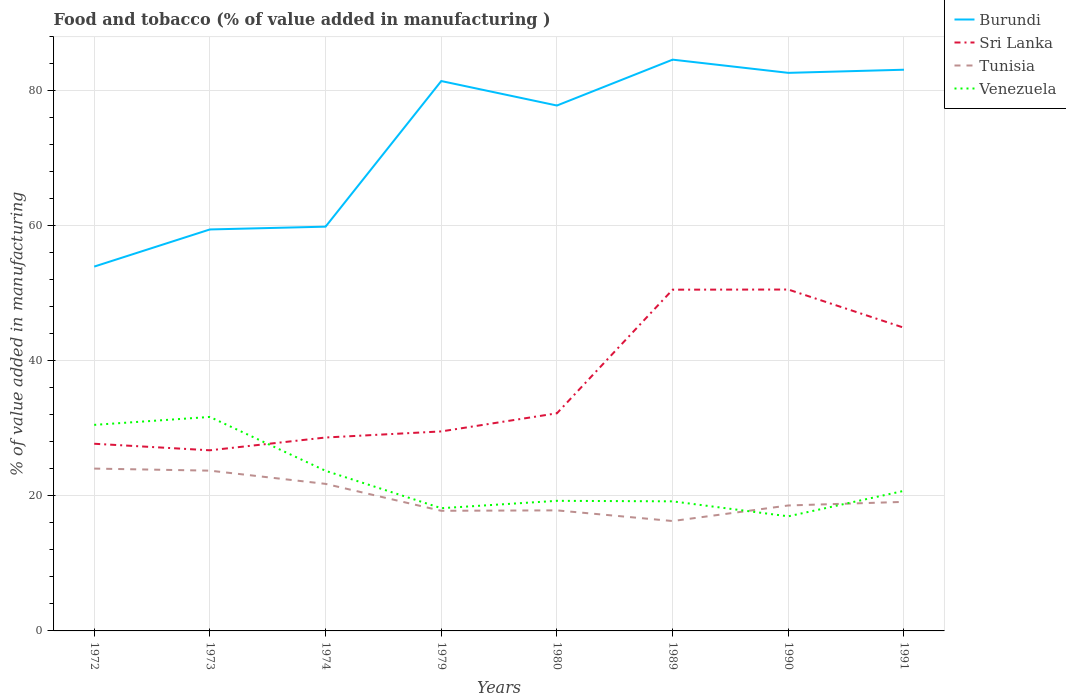How many different coloured lines are there?
Ensure brevity in your answer.  4. Is the number of lines equal to the number of legend labels?
Your answer should be compact. Yes. Across all years, what is the maximum value added in manufacturing food and tobacco in Sri Lanka?
Offer a terse response. 26.75. In which year was the value added in manufacturing food and tobacco in Tunisia maximum?
Your response must be concise. 1989. What is the total value added in manufacturing food and tobacco in Burundi in the graph?
Provide a short and direct response. -21.98. What is the difference between the highest and the second highest value added in manufacturing food and tobacco in Tunisia?
Offer a terse response. 7.77. What is the difference between the highest and the lowest value added in manufacturing food and tobacco in Venezuela?
Your answer should be very brief. 3. Is the value added in manufacturing food and tobacco in Tunisia strictly greater than the value added in manufacturing food and tobacco in Sri Lanka over the years?
Make the answer very short. Yes. How many lines are there?
Ensure brevity in your answer.  4. What is the difference between two consecutive major ticks on the Y-axis?
Your answer should be compact. 20. Are the values on the major ticks of Y-axis written in scientific E-notation?
Offer a terse response. No. Does the graph contain any zero values?
Offer a terse response. No. What is the title of the graph?
Provide a succinct answer. Food and tobacco (% of value added in manufacturing ). Does "World" appear as one of the legend labels in the graph?
Give a very brief answer. No. What is the label or title of the X-axis?
Provide a short and direct response. Years. What is the label or title of the Y-axis?
Ensure brevity in your answer.  % of value added in manufacturing. What is the % of value added in manufacturing in Burundi in 1972?
Ensure brevity in your answer.  53.96. What is the % of value added in manufacturing of Sri Lanka in 1972?
Your response must be concise. 27.72. What is the % of value added in manufacturing in Tunisia in 1972?
Provide a succinct answer. 24.04. What is the % of value added in manufacturing in Venezuela in 1972?
Your answer should be very brief. 30.52. What is the % of value added in manufacturing in Burundi in 1973?
Keep it short and to the point. 59.46. What is the % of value added in manufacturing in Sri Lanka in 1973?
Make the answer very short. 26.75. What is the % of value added in manufacturing in Tunisia in 1973?
Your answer should be very brief. 23.74. What is the % of value added in manufacturing in Venezuela in 1973?
Give a very brief answer. 31.69. What is the % of value added in manufacturing in Burundi in 1974?
Offer a very short reply. 59.87. What is the % of value added in manufacturing of Sri Lanka in 1974?
Keep it short and to the point. 28.65. What is the % of value added in manufacturing in Tunisia in 1974?
Offer a terse response. 21.78. What is the % of value added in manufacturing in Venezuela in 1974?
Keep it short and to the point. 23.71. What is the % of value added in manufacturing of Burundi in 1979?
Provide a short and direct response. 81.44. What is the % of value added in manufacturing in Sri Lanka in 1979?
Provide a succinct answer. 29.55. What is the % of value added in manufacturing in Tunisia in 1979?
Offer a very short reply. 17.79. What is the % of value added in manufacturing of Venezuela in 1979?
Keep it short and to the point. 18.18. What is the % of value added in manufacturing in Burundi in 1980?
Your answer should be compact. 77.81. What is the % of value added in manufacturing in Sri Lanka in 1980?
Offer a terse response. 32.23. What is the % of value added in manufacturing in Tunisia in 1980?
Keep it short and to the point. 17.85. What is the % of value added in manufacturing in Venezuela in 1980?
Your answer should be compact. 19.27. What is the % of value added in manufacturing in Burundi in 1989?
Your response must be concise. 84.61. What is the % of value added in manufacturing in Sri Lanka in 1989?
Provide a succinct answer. 50.54. What is the % of value added in manufacturing in Tunisia in 1989?
Provide a short and direct response. 16.27. What is the % of value added in manufacturing in Venezuela in 1989?
Your answer should be compact. 19.19. What is the % of value added in manufacturing of Burundi in 1990?
Provide a short and direct response. 82.65. What is the % of value added in manufacturing of Sri Lanka in 1990?
Keep it short and to the point. 50.56. What is the % of value added in manufacturing in Tunisia in 1990?
Your response must be concise. 18.58. What is the % of value added in manufacturing of Venezuela in 1990?
Make the answer very short. 16.97. What is the % of value added in manufacturing of Burundi in 1991?
Give a very brief answer. 83.12. What is the % of value added in manufacturing in Sri Lanka in 1991?
Offer a terse response. 44.9. What is the % of value added in manufacturing of Tunisia in 1991?
Give a very brief answer. 19.11. What is the % of value added in manufacturing of Venezuela in 1991?
Your answer should be very brief. 20.75. Across all years, what is the maximum % of value added in manufacturing in Burundi?
Offer a terse response. 84.61. Across all years, what is the maximum % of value added in manufacturing in Sri Lanka?
Offer a terse response. 50.56. Across all years, what is the maximum % of value added in manufacturing of Tunisia?
Offer a very short reply. 24.04. Across all years, what is the maximum % of value added in manufacturing of Venezuela?
Your answer should be very brief. 31.69. Across all years, what is the minimum % of value added in manufacturing of Burundi?
Your answer should be compact. 53.96. Across all years, what is the minimum % of value added in manufacturing of Sri Lanka?
Give a very brief answer. 26.75. Across all years, what is the minimum % of value added in manufacturing in Tunisia?
Keep it short and to the point. 16.27. Across all years, what is the minimum % of value added in manufacturing of Venezuela?
Ensure brevity in your answer.  16.97. What is the total % of value added in manufacturing in Burundi in the graph?
Your answer should be very brief. 582.91. What is the total % of value added in manufacturing of Sri Lanka in the graph?
Your answer should be very brief. 290.89. What is the total % of value added in manufacturing in Tunisia in the graph?
Make the answer very short. 159.17. What is the total % of value added in manufacturing in Venezuela in the graph?
Provide a succinct answer. 180.27. What is the difference between the % of value added in manufacturing in Burundi in 1972 and that in 1973?
Your answer should be compact. -5.5. What is the difference between the % of value added in manufacturing of Sri Lanka in 1972 and that in 1973?
Your answer should be compact. 0.97. What is the difference between the % of value added in manufacturing of Tunisia in 1972 and that in 1973?
Provide a succinct answer. 0.31. What is the difference between the % of value added in manufacturing in Venezuela in 1972 and that in 1973?
Make the answer very short. -1.18. What is the difference between the % of value added in manufacturing of Burundi in 1972 and that in 1974?
Make the answer very short. -5.91. What is the difference between the % of value added in manufacturing in Sri Lanka in 1972 and that in 1974?
Make the answer very short. -0.92. What is the difference between the % of value added in manufacturing in Tunisia in 1972 and that in 1974?
Keep it short and to the point. 2.27. What is the difference between the % of value added in manufacturing in Venezuela in 1972 and that in 1974?
Provide a short and direct response. 6.8. What is the difference between the % of value added in manufacturing in Burundi in 1972 and that in 1979?
Give a very brief answer. -27.48. What is the difference between the % of value added in manufacturing in Sri Lanka in 1972 and that in 1979?
Offer a terse response. -1.83. What is the difference between the % of value added in manufacturing of Tunisia in 1972 and that in 1979?
Give a very brief answer. 6.25. What is the difference between the % of value added in manufacturing in Venezuela in 1972 and that in 1979?
Your answer should be very brief. 12.34. What is the difference between the % of value added in manufacturing of Burundi in 1972 and that in 1980?
Provide a short and direct response. -23.85. What is the difference between the % of value added in manufacturing in Sri Lanka in 1972 and that in 1980?
Your answer should be very brief. -4.51. What is the difference between the % of value added in manufacturing of Tunisia in 1972 and that in 1980?
Provide a succinct answer. 6.19. What is the difference between the % of value added in manufacturing in Venezuela in 1972 and that in 1980?
Keep it short and to the point. 11.25. What is the difference between the % of value added in manufacturing in Burundi in 1972 and that in 1989?
Provide a succinct answer. -30.65. What is the difference between the % of value added in manufacturing of Sri Lanka in 1972 and that in 1989?
Offer a terse response. -22.82. What is the difference between the % of value added in manufacturing in Tunisia in 1972 and that in 1989?
Your response must be concise. 7.77. What is the difference between the % of value added in manufacturing of Venezuela in 1972 and that in 1989?
Your answer should be compact. 11.32. What is the difference between the % of value added in manufacturing of Burundi in 1972 and that in 1990?
Give a very brief answer. -28.69. What is the difference between the % of value added in manufacturing of Sri Lanka in 1972 and that in 1990?
Offer a terse response. -22.84. What is the difference between the % of value added in manufacturing in Tunisia in 1972 and that in 1990?
Your answer should be very brief. 5.46. What is the difference between the % of value added in manufacturing in Venezuela in 1972 and that in 1990?
Your answer should be very brief. 13.54. What is the difference between the % of value added in manufacturing of Burundi in 1972 and that in 1991?
Your response must be concise. -29.16. What is the difference between the % of value added in manufacturing of Sri Lanka in 1972 and that in 1991?
Give a very brief answer. -17.18. What is the difference between the % of value added in manufacturing in Tunisia in 1972 and that in 1991?
Your answer should be very brief. 4.93. What is the difference between the % of value added in manufacturing of Venezuela in 1972 and that in 1991?
Provide a succinct answer. 9.77. What is the difference between the % of value added in manufacturing of Burundi in 1973 and that in 1974?
Your answer should be very brief. -0.41. What is the difference between the % of value added in manufacturing of Sri Lanka in 1973 and that in 1974?
Your response must be concise. -1.89. What is the difference between the % of value added in manufacturing of Tunisia in 1973 and that in 1974?
Your response must be concise. 1.96. What is the difference between the % of value added in manufacturing in Venezuela in 1973 and that in 1974?
Ensure brevity in your answer.  7.98. What is the difference between the % of value added in manufacturing of Burundi in 1973 and that in 1979?
Offer a terse response. -21.98. What is the difference between the % of value added in manufacturing of Sri Lanka in 1973 and that in 1979?
Your answer should be very brief. -2.8. What is the difference between the % of value added in manufacturing in Tunisia in 1973 and that in 1979?
Offer a very short reply. 5.94. What is the difference between the % of value added in manufacturing in Venezuela in 1973 and that in 1979?
Make the answer very short. 13.52. What is the difference between the % of value added in manufacturing in Burundi in 1973 and that in 1980?
Make the answer very short. -18.35. What is the difference between the % of value added in manufacturing of Sri Lanka in 1973 and that in 1980?
Make the answer very short. -5.48. What is the difference between the % of value added in manufacturing of Tunisia in 1973 and that in 1980?
Make the answer very short. 5.88. What is the difference between the % of value added in manufacturing in Venezuela in 1973 and that in 1980?
Your response must be concise. 12.42. What is the difference between the % of value added in manufacturing in Burundi in 1973 and that in 1989?
Offer a terse response. -25.15. What is the difference between the % of value added in manufacturing in Sri Lanka in 1973 and that in 1989?
Keep it short and to the point. -23.79. What is the difference between the % of value added in manufacturing in Tunisia in 1973 and that in 1989?
Your response must be concise. 7.46. What is the difference between the % of value added in manufacturing in Venezuela in 1973 and that in 1989?
Give a very brief answer. 12.5. What is the difference between the % of value added in manufacturing in Burundi in 1973 and that in 1990?
Offer a terse response. -23.19. What is the difference between the % of value added in manufacturing in Sri Lanka in 1973 and that in 1990?
Provide a short and direct response. -23.81. What is the difference between the % of value added in manufacturing of Tunisia in 1973 and that in 1990?
Provide a succinct answer. 5.16. What is the difference between the % of value added in manufacturing of Venezuela in 1973 and that in 1990?
Make the answer very short. 14.72. What is the difference between the % of value added in manufacturing in Burundi in 1973 and that in 1991?
Provide a short and direct response. -23.66. What is the difference between the % of value added in manufacturing of Sri Lanka in 1973 and that in 1991?
Ensure brevity in your answer.  -18.15. What is the difference between the % of value added in manufacturing in Tunisia in 1973 and that in 1991?
Give a very brief answer. 4.62. What is the difference between the % of value added in manufacturing of Venezuela in 1973 and that in 1991?
Give a very brief answer. 10.94. What is the difference between the % of value added in manufacturing of Burundi in 1974 and that in 1979?
Your answer should be compact. -21.57. What is the difference between the % of value added in manufacturing in Sri Lanka in 1974 and that in 1979?
Keep it short and to the point. -0.9. What is the difference between the % of value added in manufacturing of Tunisia in 1974 and that in 1979?
Keep it short and to the point. 3.99. What is the difference between the % of value added in manufacturing in Venezuela in 1974 and that in 1979?
Provide a succinct answer. 5.54. What is the difference between the % of value added in manufacturing in Burundi in 1974 and that in 1980?
Give a very brief answer. -17.94. What is the difference between the % of value added in manufacturing in Sri Lanka in 1974 and that in 1980?
Give a very brief answer. -3.59. What is the difference between the % of value added in manufacturing in Tunisia in 1974 and that in 1980?
Keep it short and to the point. 3.92. What is the difference between the % of value added in manufacturing of Venezuela in 1974 and that in 1980?
Give a very brief answer. 4.45. What is the difference between the % of value added in manufacturing in Burundi in 1974 and that in 1989?
Your answer should be very brief. -24.74. What is the difference between the % of value added in manufacturing of Sri Lanka in 1974 and that in 1989?
Keep it short and to the point. -21.89. What is the difference between the % of value added in manufacturing of Tunisia in 1974 and that in 1989?
Your answer should be very brief. 5.5. What is the difference between the % of value added in manufacturing in Venezuela in 1974 and that in 1989?
Make the answer very short. 4.52. What is the difference between the % of value added in manufacturing of Burundi in 1974 and that in 1990?
Your answer should be very brief. -22.78. What is the difference between the % of value added in manufacturing in Sri Lanka in 1974 and that in 1990?
Ensure brevity in your answer.  -21.92. What is the difference between the % of value added in manufacturing in Tunisia in 1974 and that in 1990?
Offer a very short reply. 3.2. What is the difference between the % of value added in manufacturing of Venezuela in 1974 and that in 1990?
Provide a short and direct response. 6.74. What is the difference between the % of value added in manufacturing in Burundi in 1974 and that in 1991?
Provide a short and direct response. -23.24. What is the difference between the % of value added in manufacturing of Sri Lanka in 1974 and that in 1991?
Provide a short and direct response. -16.25. What is the difference between the % of value added in manufacturing of Tunisia in 1974 and that in 1991?
Your answer should be very brief. 2.66. What is the difference between the % of value added in manufacturing of Venezuela in 1974 and that in 1991?
Offer a very short reply. 2.96. What is the difference between the % of value added in manufacturing in Burundi in 1979 and that in 1980?
Ensure brevity in your answer.  3.62. What is the difference between the % of value added in manufacturing in Sri Lanka in 1979 and that in 1980?
Provide a succinct answer. -2.68. What is the difference between the % of value added in manufacturing of Tunisia in 1979 and that in 1980?
Make the answer very short. -0.06. What is the difference between the % of value added in manufacturing of Venezuela in 1979 and that in 1980?
Give a very brief answer. -1.09. What is the difference between the % of value added in manufacturing of Burundi in 1979 and that in 1989?
Make the answer very short. -3.17. What is the difference between the % of value added in manufacturing of Sri Lanka in 1979 and that in 1989?
Offer a terse response. -20.99. What is the difference between the % of value added in manufacturing of Tunisia in 1979 and that in 1989?
Ensure brevity in your answer.  1.52. What is the difference between the % of value added in manufacturing of Venezuela in 1979 and that in 1989?
Provide a succinct answer. -1.01. What is the difference between the % of value added in manufacturing of Burundi in 1979 and that in 1990?
Offer a very short reply. -1.21. What is the difference between the % of value added in manufacturing in Sri Lanka in 1979 and that in 1990?
Your response must be concise. -21.01. What is the difference between the % of value added in manufacturing of Tunisia in 1979 and that in 1990?
Provide a short and direct response. -0.79. What is the difference between the % of value added in manufacturing in Venezuela in 1979 and that in 1990?
Your answer should be very brief. 1.2. What is the difference between the % of value added in manufacturing of Burundi in 1979 and that in 1991?
Your answer should be compact. -1.68. What is the difference between the % of value added in manufacturing in Sri Lanka in 1979 and that in 1991?
Ensure brevity in your answer.  -15.35. What is the difference between the % of value added in manufacturing in Tunisia in 1979 and that in 1991?
Offer a very short reply. -1.32. What is the difference between the % of value added in manufacturing in Venezuela in 1979 and that in 1991?
Your answer should be compact. -2.57. What is the difference between the % of value added in manufacturing of Burundi in 1980 and that in 1989?
Your answer should be very brief. -6.79. What is the difference between the % of value added in manufacturing of Sri Lanka in 1980 and that in 1989?
Offer a very short reply. -18.31. What is the difference between the % of value added in manufacturing in Tunisia in 1980 and that in 1989?
Your answer should be compact. 1.58. What is the difference between the % of value added in manufacturing of Venezuela in 1980 and that in 1989?
Make the answer very short. 0.08. What is the difference between the % of value added in manufacturing of Burundi in 1980 and that in 1990?
Offer a terse response. -4.84. What is the difference between the % of value added in manufacturing of Sri Lanka in 1980 and that in 1990?
Provide a succinct answer. -18.33. What is the difference between the % of value added in manufacturing in Tunisia in 1980 and that in 1990?
Your answer should be very brief. -0.73. What is the difference between the % of value added in manufacturing in Venezuela in 1980 and that in 1990?
Provide a short and direct response. 2.3. What is the difference between the % of value added in manufacturing in Burundi in 1980 and that in 1991?
Ensure brevity in your answer.  -5.3. What is the difference between the % of value added in manufacturing of Sri Lanka in 1980 and that in 1991?
Provide a succinct answer. -12.67. What is the difference between the % of value added in manufacturing of Tunisia in 1980 and that in 1991?
Make the answer very short. -1.26. What is the difference between the % of value added in manufacturing in Venezuela in 1980 and that in 1991?
Keep it short and to the point. -1.48. What is the difference between the % of value added in manufacturing in Burundi in 1989 and that in 1990?
Make the answer very short. 1.96. What is the difference between the % of value added in manufacturing in Sri Lanka in 1989 and that in 1990?
Keep it short and to the point. -0.02. What is the difference between the % of value added in manufacturing in Tunisia in 1989 and that in 1990?
Your answer should be compact. -2.31. What is the difference between the % of value added in manufacturing of Venezuela in 1989 and that in 1990?
Provide a succinct answer. 2.22. What is the difference between the % of value added in manufacturing in Burundi in 1989 and that in 1991?
Your answer should be very brief. 1.49. What is the difference between the % of value added in manufacturing in Sri Lanka in 1989 and that in 1991?
Provide a short and direct response. 5.64. What is the difference between the % of value added in manufacturing in Tunisia in 1989 and that in 1991?
Make the answer very short. -2.84. What is the difference between the % of value added in manufacturing of Venezuela in 1989 and that in 1991?
Offer a very short reply. -1.56. What is the difference between the % of value added in manufacturing in Burundi in 1990 and that in 1991?
Your response must be concise. -0.47. What is the difference between the % of value added in manufacturing of Sri Lanka in 1990 and that in 1991?
Your response must be concise. 5.66. What is the difference between the % of value added in manufacturing in Tunisia in 1990 and that in 1991?
Offer a terse response. -0.53. What is the difference between the % of value added in manufacturing of Venezuela in 1990 and that in 1991?
Provide a succinct answer. -3.78. What is the difference between the % of value added in manufacturing of Burundi in 1972 and the % of value added in manufacturing of Sri Lanka in 1973?
Your response must be concise. 27.21. What is the difference between the % of value added in manufacturing in Burundi in 1972 and the % of value added in manufacturing in Tunisia in 1973?
Give a very brief answer. 30.22. What is the difference between the % of value added in manufacturing in Burundi in 1972 and the % of value added in manufacturing in Venezuela in 1973?
Make the answer very short. 22.27. What is the difference between the % of value added in manufacturing in Sri Lanka in 1972 and the % of value added in manufacturing in Tunisia in 1973?
Give a very brief answer. 3.98. What is the difference between the % of value added in manufacturing in Sri Lanka in 1972 and the % of value added in manufacturing in Venezuela in 1973?
Offer a terse response. -3.97. What is the difference between the % of value added in manufacturing of Tunisia in 1972 and the % of value added in manufacturing of Venezuela in 1973?
Give a very brief answer. -7.65. What is the difference between the % of value added in manufacturing of Burundi in 1972 and the % of value added in manufacturing of Sri Lanka in 1974?
Your answer should be compact. 25.31. What is the difference between the % of value added in manufacturing in Burundi in 1972 and the % of value added in manufacturing in Tunisia in 1974?
Your response must be concise. 32.18. What is the difference between the % of value added in manufacturing of Burundi in 1972 and the % of value added in manufacturing of Venezuela in 1974?
Offer a very short reply. 30.25. What is the difference between the % of value added in manufacturing of Sri Lanka in 1972 and the % of value added in manufacturing of Tunisia in 1974?
Your answer should be compact. 5.94. What is the difference between the % of value added in manufacturing of Sri Lanka in 1972 and the % of value added in manufacturing of Venezuela in 1974?
Keep it short and to the point. 4.01. What is the difference between the % of value added in manufacturing in Tunisia in 1972 and the % of value added in manufacturing in Venezuela in 1974?
Offer a very short reply. 0.33. What is the difference between the % of value added in manufacturing in Burundi in 1972 and the % of value added in manufacturing in Sri Lanka in 1979?
Give a very brief answer. 24.41. What is the difference between the % of value added in manufacturing in Burundi in 1972 and the % of value added in manufacturing in Tunisia in 1979?
Give a very brief answer. 36.17. What is the difference between the % of value added in manufacturing in Burundi in 1972 and the % of value added in manufacturing in Venezuela in 1979?
Offer a very short reply. 35.78. What is the difference between the % of value added in manufacturing in Sri Lanka in 1972 and the % of value added in manufacturing in Tunisia in 1979?
Your response must be concise. 9.93. What is the difference between the % of value added in manufacturing in Sri Lanka in 1972 and the % of value added in manufacturing in Venezuela in 1979?
Your answer should be very brief. 9.54. What is the difference between the % of value added in manufacturing in Tunisia in 1972 and the % of value added in manufacturing in Venezuela in 1979?
Ensure brevity in your answer.  5.87. What is the difference between the % of value added in manufacturing in Burundi in 1972 and the % of value added in manufacturing in Sri Lanka in 1980?
Keep it short and to the point. 21.73. What is the difference between the % of value added in manufacturing of Burundi in 1972 and the % of value added in manufacturing of Tunisia in 1980?
Offer a terse response. 36.1. What is the difference between the % of value added in manufacturing of Burundi in 1972 and the % of value added in manufacturing of Venezuela in 1980?
Your answer should be compact. 34.69. What is the difference between the % of value added in manufacturing in Sri Lanka in 1972 and the % of value added in manufacturing in Tunisia in 1980?
Make the answer very short. 9.87. What is the difference between the % of value added in manufacturing in Sri Lanka in 1972 and the % of value added in manufacturing in Venezuela in 1980?
Provide a short and direct response. 8.45. What is the difference between the % of value added in manufacturing of Tunisia in 1972 and the % of value added in manufacturing of Venezuela in 1980?
Your answer should be very brief. 4.78. What is the difference between the % of value added in manufacturing in Burundi in 1972 and the % of value added in manufacturing in Sri Lanka in 1989?
Provide a succinct answer. 3.42. What is the difference between the % of value added in manufacturing of Burundi in 1972 and the % of value added in manufacturing of Tunisia in 1989?
Make the answer very short. 37.68. What is the difference between the % of value added in manufacturing in Burundi in 1972 and the % of value added in manufacturing in Venezuela in 1989?
Offer a very short reply. 34.77. What is the difference between the % of value added in manufacturing of Sri Lanka in 1972 and the % of value added in manufacturing of Tunisia in 1989?
Your answer should be compact. 11.45. What is the difference between the % of value added in manufacturing in Sri Lanka in 1972 and the % of value added in manufacturing in Venezuela in 1989?
Ensure brevity in your answer.  8.53. What is the difference between the % of value added in manufacturing in Tunisia in 1972 and the % of value added in manufacturing in Venezuela in 1989?
Ensure brevity in your answer.  4.85. What is the difference between the % of value added in manufacturing in Burundi in 1972 and the % of value added in manufacturing in Sri Lanka in 1990?
Your answer should be very brief. 3.4. What is the difference between the % of value added in manufacturing of Burundi in 1972 and the % of value added in manufacturing of Tunisia in 1990?
Make the answer very short. 35.38. What is the difference between the % of value added in manufacturing in Burundi in 1972 and the % of value added in manufacturing in Venezuela in 1990?
Offer a very short reply. 36.99. What is the difference between the % of value added in manufacturing in Sri Lanka in 1972 and the % of value added in manufacturing in Tunisia in 1990?
Your response must be concise. 9.14. What is the difference between the % of value added in manufacturing in Sri Lanka in 1972 and the % of value added in manufacturing in Venezuela in 1990?
Ensure brevity in your answer.  10.75. What is the difference between the % of value added in manufacturing of Tunisia in 1972 and the % of value added in manufacturing of Venezuela in 1990?
Your response must be concise. 7.07. What is the difference between the % of value added in manufacturing of Burundi in 1972 and the % of value added in manufacturing of Sri Lanka in 1991?
Make the answer very short. 9.06. What is the difference between the % of value added in manufacturing in Burundi in 1972 and the % of value added in manufacturing in Tunisia in 1991?
Keep it short and to the point. 34.85. What is the difference between the % of value added in manufacturing in Burundi in 1972 and the % of value added in manufacturing in Venezuela in 1991?
Offer a very short reply. 33.21. What is the difference between the % of value added in manufacturing in Sri Lanka in 1972 and the % of value added in manufacturing in Tunisia in 1991?
Your answer should be very brief. 8.61. What is the difference between the % of value added in manufacturing in Sri Lanka in 1972 and the % of value added in manufacturing in Venezuela in 1991?
Provide a succinct answer. 6.97. What is the difference between the % of value added in manufacturing in Tunisia in 1972 and the % of value added in manufacturing in Venezuela in 1991?
Give a very brief answer. 3.29. What is the difference between the % of value added in manufacturing in Burundi in 1973 and the % of value added in manufacturing in Sri Lanka in 1974?
Offer a terse response. 30.81. What is the difference between the % of value added in manufacturing in Burundi in 1973 and the % of value added in manufacturing in Tunisia in 1974?
Provide a succinct answer. 37.68. What is the difference between the % of value added in manufacturing of Burundi in 1973 and the % of value added in manufacturing of Venezuela in 1974?
Ensure brevity in your answer.  35.75. What is the difference between the % of value added in manufacturing in Sri Lanka in 1973 and the % of value added in manufacturing in Tunisia in 1974?
Keep it short and to the point. 4.97. What is the difference between the % of value added in manufacturing of Sri Lanka in 1973 and the % of value added in manufacturing of Venezuela in 1974?
Your answer should be compact. 3.04. What is the difference between the % of value added in manufacturing in Tunisia in 1973 and the % of value added in manufacturing in Venezuela in 1974?
Provide a short and direct response. 0.02. What is the difference between the % of value added in manufacturing in Burundi in 1973 and the % of value added in manufacturing in Sri Lanka in 1979?
Provide a short and direct response. 29.91. What is the difference between the % of value added in manufacturing of Burundi in 1973 and the % of value added in manufacturing of Tunisia in 1979?
Your response must be concise. 41.67. What is the difference between the % of value added in manufacturing of Burundi in 1973 and the % of value added in manufacturing of Venezuela in 1979?
Provide a succinct answer. 41.28. What is the difference between the % of value added in manufacturing in Sri Lanka in 1973 and the % of value added in manufacturing in Tunisia in 1979?
Keep it short and to the point. 8.96. What is the difference between the % of value added in manufacturing of Sri Lanka in 1973 and the % of value added in manufacturing of Venezuela in 1979?
Your response must be concise. 8.58. What is the difference between the % of value added in manufacturing of Tunisia in 1973 and the % of value added in manufacturing of Venezuela in 1979?
Your answer should be compact. 5.56. What is the difference between the % of value added in manufacturing of Burundi in 1973 and the % of value added in manufacturing of Sri Lanka in 1980?
Your response must be concise. 27.23. What is the difference between the % of value added in manufacturing in Burundi in 1973 and the % of value added in manufacturing in Tunisia in 1980?
Provide a succinct answer. 41.6. What is the difference between the % of value added in manufacturing in Burundi in 1973 and the % of value added in manufacturing in Venezuela in 1980?
Make the answer very short. 40.19. What is the difference between the % of value added in manufacturing of Sri Lanka in 1973 and the % of value added in manufacturing of Tunisia in 1980?
Offer a terse response. 8.9. What is the difference between the % of value added in manufacturing in Sri Lanka in 1973 and the % of value added in manufacturing in Venezuela in 1980?
Your answer should be very brief. 7.48. What is the difference between the % of value added in manufacturing in Tunisia in 1973 and the % of value added in manufacturing in Venezuela in 1980?
Offer a very short reply. 4.47. What is the difference between the % of value added in manufacturing in Burundi in 1973 and the % of value added in manufacturing in Sri Lanka in 1989?
Give a very brief answer. 8.92. What is the difference between the % of value added in manufacturing in Burundi in 1973 and the % of value added in manufacturing in Tunisia in 1989?
Make the answer very short. 43.19. What is the difference between the % of value added in manufacturing in Burundi in 1973 and the % of value added in manufacturing in Venezuela in 1989?
Offer a very short reply. 40.27. What is the difference between the % of value added in manufacturing in Sri Lanka in 1973 and the % of value added in manufacturing in Tunisia in 1989?
Your answer should be compact. 10.48. What is the difference between the % of value added in manufacturing in Sri Lanka in 1973 and the % of value added in manufacturing in Venezuela in 1989?
Provide a succinct answer. 7.56. What is the difference between the % of value added in manufacturing of Tunisia in 1973 and the % of value added in manufacturing of Venezuela in 1989?
Your answer should be very brief. 4.55. What is the difference between the % of value added in manufacturing of Burundi in 1973 and the % of value added in manufacturing of Sri Lanka in 1990?
Your answer should be very brief. 8.9. What is the difference between the % of value added in manufacturing of Burundi in 1973 and the % of value added in manufacturing of Tunisia in 1990?
Offer a very short reply. 40.88. What is the difference between the % of value added in manufacturing in Burundi in 1973 and the % of value added in manufacturing in Venezuela in 1990?
Give a very brief answer. 42.49. What is the difference between the % of value added in manufacturing of Sri Lanka in 1973 and the % of value added in manufacturing of Tunisia in 1990?
Offer a very short reply. 8.17. What is the difference between the % of value added in manufacturing of Sri Lanka in 1973 and the % of value added in manufacturing of Venezuela in 1990?
Provide a short and direct response. 9.78. What is the difference between the % of value added in manufacturing in Tunisia in 1973 and the % of value added in manufacturing in Venezuela in 1990?
Give a very brief answer. 6.76. What is the difference between the % of value added in manufacturing in Burundi in 1973 and the % of value added in manufacturing in Sri Lanka in 1991?
Your answer should be very brief. 14.56. What is the difference between the % of value added in manufacturing of Burundi in 1973 and the % of value added in manufacturing of Tunisia in 1991?
Make the answer very short. 40.35. What is the difference between the % of value added in manufacturing of Burundi in 1973 and the % of value added in manufacturing of Venezuela in 1991?
Your response must be concise. 38.71. What is the difference between the % of value added in manufacturing in Sri Lanka in 1973 and the % of value added in manufacturing in Tunisia in 1991?
Provide a succinct answer. 7.64. What is the difference between the % of value added in manufacturing in Sri Lanka in 1973 and the % of value added in manufacturing in Venezuela in 1991?
Offer a terse response. 6. What is the difference between the % of value added in manufacturing of Tunisia in 1973 and the % of value added in manufacturing of Venezuela in 1991?
Your response must be concise. 2.99. What is the difference between the % of value added in manufacturing of Burundi in 1974 and the % of value added in manufacturing of Sri Lanka in 1979?
Provide a succinct answer. 30.32. What is the difference between the % of value added in manufacturing of Burundi in 1974 and the % of value added in manufacturing of Tunisia in 1979?
Provide a short and direct response. 42.08. What is the difference between the % of value added in manufacturing of Burundi in 1974 and the % of value added in manufacturing of Venezuela in 1979?
Provide a succinct answer. 41.7. What is the difference between the % of value added in manufacturing of Sri Lanka in 1974 and the % of value added in manufacturing of Tunisia in 1979?
Your answer should be compact. 10.85. What is the difference between the % of value added in manufacturing in Sri Lanka in 1974 and the % of value added in manufacturing in Venezuela in 1979?
Your answer should be compact. 10.47. What is the difference between the % of value added in manufacturing of Tunisia in 1974 and the % of value added in manufacturing of Venezuela in 1979?
Provide a short and direct response. 3.6. What is the difference between the % of value added in manufacturing in Burundi in 1974 and the % of value added in manufacturing in Sri Lanka in 1980?
Provide a short and direct response. 27.64. What is the difference between the % of value added in manufacturing of Burundi in 1974 and the % of value added in manufacturing of Tunisia in 1980?
Offer a terse response. 42.02. What is the difference between the % of value added in manufacturing in Burundi in 1974 and the % of value added in manufacturing in Venezuela in 1980?
Ensure brevity in your answer.  40.6. What is the difference between the % of value added in manufacturing of Sri Lanka in 1974 and the % of value added in manufacturing of Tunisia in 1980?
Keep it short and to the point. 10.79. What is the difference between the % of value added in manufacturing in Sri Lanka in 1974 and the % of value added in manufacturing in Venezuela in 1980?
Keep it short and to the point. 9.38. What is the difference between the % of value added in manufacturing in Tunisia in 1974 and the % of value added in manufacturing in Venezuela in 1980?
Your answer should be very brief. 2.51. What is the difference between the % of value added in manufacturing of Burundi in 1974 and the % of value added in manufacturing of Sri Lanka in 1989?
Ensure brevity in your answer.  9.33. What is the difference between the % of value added in manufacturing of Burundi in 1974 and the % of value added in manufacturing of Tunisia in 1989?
Give a very brief answer. 43.6. What is the difference between the % of value added in manufacturing in Burundi in 1974 and the % of value added in manufacturing in Venezuela in 1989?
Provide a succinct answer. 40.68. What is the difference between the % of value added in manufacturing of Sri Lanka in 1974 and the % of value added in manufacturing of Tunisia in 1989?
Provide a short and direct response. 12.37. What is the difference between the % of value added in manufacturing of Sri Lanka in 1974 and the % of value added in manufacturing of Venezuela in 1989?
Your answer should be very brief. 9.45. What is the difference between the % of value added in manufacturing of Tunisia in 1974 and the % of value added in manufacturing of Venezuela in 1989?
Your answer should be compact. 2.59. What is the difference between the % of value added in manufacturing in Burundi in 1974 and the % of value added in manufacturing in Sri Lanka in 1990?
Your response must be concise. 9.31. What is the difference between the % of value added in manufacturing of Burundi in 1974 and the % of value added in manufacturing of Tunisia in 1990?
Make the answer very short. 41.29. What is the difference between the % of value added in manufacturing in Burundi in 1974 and the % of value added in manufacturing in Venezuela in 1990?
Ensure brevity in your answer.  42.9. What is the difference between the % of value added in manufacturing of Sri Lanka in 1974 and the % of value added in manufacturing of Tunisia in 1990?
Offer a very short reply. 10.07. What is the difference between the % of value added in manufacturing of Sri Lanka in 1974 and the % of value added in manufacturing of Venezuela in 1990?
Give a very brief answer. 11.67. What is the difference between the % of value added in manufacturing in Tunisia in 1974 and the % of value added in manufacturing in Venezuela in 1990?
Your answer should be very brief. 4.81. What is the difference between the % of value added in manufacturing in Burundi in 1974 and the % of value added in manufacturing in Sri Lanka in 1991?
Your response must be concise. 14.97. What is the difference between the % of value added in manufacturing in Burundi in 1974 and the % of value added in manufacturing in Tunisia in 1991?
Provide a short and direct response. 40.76. What is the difference between the % of value added in manufacturing of Burundi in 1974 and the % of value added in manufacturing of Venezuela in 1991?
Keep it short and to the point. 39.12. What is the difference between the % of value added in manufacturing of Sri Lanka in 1974 and the % of value added in manufacturing of Tunisia in 1991?
Provide a short and direct response. 9.53. What is the difference between the % of value added in manufacturing in Sri Lanka in 1974 and the % of value added in manufacturing in Venezuela in 1991?
Offer a very short reply. 7.9. What is the difference between the % of value added in manufacturing in Tunisia in 1974 and the % of value added in manufacturing in Venezuela in 1991?
Provide a succinct answer. 1.03. What is the difference between the % of value added in manufacturing in Burundi in 1979 and the % of value added in manufacturing in Sri Lanka in 1980?
Make the answer very short. 49.21. What is the difference between the % of value added in manufacturing in Burundi in 1979 and the % of value added in manufacturing in Tunisia in 1980?
Provide a succinct answer. 63.58. What is the difference between the % of value added in manufacturing of Burundi in 1979 and the % of value added in manufacturing of Venezuela in 1980?
Your answer should be compact. 62.17. What is the difference between the % of value added in manufacturing in Sri Lanka in 1979 and the % of value added in manufacturing in Tunisia in 1980?
Keep it short and to the point. 11.69. What is the difference between the % of value added in manufacturing in Sri Lanka in 1979 and the % of value added in manufacturing in Venezuela in 1980?
Your answer should be very brief. 10.28. What is the difference between the % of value added in manufacturing of Tunisia in 1979 and the % of value added in manufacturing of Venezuela in 1980?
Your response must be concise. -1.48. What is the difference between the % of value added in manufacturing of Burundi in 1979 and the % of value added in manufacturing of Sri Lanka in 1989?
Offer a terse response. 30.9. What is the difference between the % of value added in manufacturing of Burundi in 1979 and the % of value added in manufacturing of Tunisia in 1989?
Provide a succinct answer. 65.16. What is the difference between the % of value added in manufacturing in Burundi in 1979 and the % of value added in manufacturing in Venezuela in 1989?
Give a very brief answer. 62.25. What is the difference between the % of value added in manufacturing of Sri Lanka in 1979 and the % of value added in manufacturing of Tunisia in 1989?
Your response must be concise. 13.27. What is the difference between the % of value added in manufacturing in Sri Lanka in 1979 and the % of value added in manufacturing in Venezuela in 1989?
Ensure brevity in your answer.  10.36. What is the difference between the % of value added in manufacturing of Tunisia in 1979 and the % of value added in manufacturing of Venezuela in 1989?
Offer a terse response. -1.4. What is the difference between the % of value added in manufacturing of Burundi in 1979 and the % of value added in manufacturing of Sri Lanka in 1990?
Your response must be concise. 30.88. What is the difference between the % of value added in manufacturing in Burundi in 1979 and the % of value added in manufacturing in Tunisia in 1990?
Provide a succinct answer. 62.86. What is the difference between the % of value added in manufacturing in Burundi in 1979 and the % of value added in manufacturing in Venezuela in 1990?
Provide a succinct answer. 64.47. What is the difference between the % of value added in manufacturing in Sri Lanka in 1979 and the % of value added in manufacturing in Tunisia in 1990?
Provide a short and direct response. 10.97. What is the difference between the % of value added in manufacturing of Sri Lanka in 1979 and the % of value added in manufacturing of Venezuela in 1990?
Offer a very short reply. 12.58. What is the difference between the % of value added in manufacturing of Tunisia in 1979 and the % of value added in manufacturing of Venezuela in 1990?
Your response must be concise. 0.82. What is the difference between the % of value added in manufacturing in Burundi in 1979 and the % of value added in manufacturing in Sri Lanka in 1991?
Provide a short and direct response. 36.54. What is the difference between the % of value added in manufacturing in Burundi in 1979 and the % of value added in manufacturing in Tunisia in 1991?
Offer a very short reply. 62.33. What is the difference between the % of value added in manufacturing in Burundi in 1979 and the % of value added in manufacturing in Venezuela in 1991?
Ensure brevity in your answer.  60.69. What is the difference between the % of value added in manufacturing of Sri Lanka in 1979 and the % of value added in manufacturing of Tunisia in 1991?
Your response must be concise. 10.43. What is the difference between the % of value added in manufacturing of Sri Lanka in 1979 and the % of value added in manufacturing of Venezuela in 1991?
Offer a very short reply. 8.8. What is the difference between the % of value added in manufacturing of Tunisia in 1979 and the % of value added in manufacturing of Venezuela in 1991?
Your answer should be compact. -2.96. What is the difference between the % of value added in manufacturing of Burundi in 1980 and the % of value added in manufacturing of Sri Lanka in 1989?
Your answer should be compact. 27.27. What is the difference between the % of value added in manufacturing of Burundi in 1980 and the % of value added in manufacturing of Tunisia in 1989?
Your response must be concise. 61.54. What is the difference between the % of value added in manufacturing of Burundi in 1980 and the % of value added in manufacturing of Venezuela in 1989?
Offer a very short reply. 58.62. What is the difference between the % of value added in manufacturing of Sri Lanka in 1980 and the % of value added in manufacturing of Tunisia in 1989?
Provide a succinct answer. 15.96. What is the difference between the % of value added in manufacturing in Sri Lanka in 1980 and the % of value added in manufacturing in Venezuela in 1989?
Offer a very short reply. 13.04. What is the difference between the % of value added in manufacturing of Tunisia in 1980 and the % of value added in manufacturing of Venezuela in 1989?
Offer a very short reply. -1.34. What is the difference between the % of value added in manufacturing in Burundi in 1980 and the % of value added in manufacturing in Sri Lanka in 1990?
Offer a very short reply. 27.25. What is the difference between the % of value added in manufacturing of Burundi in 1980 and the % of value added in manufacturing of Tunisia in 1990?
Your answer should be compact. 59.23. What is the difference between the % of value added in manufacturing of Burundi in 1980 and the % of value added in manufacturing of Venezuela in 1990?
Offer a terse response. 60.84. What is the difference between the % of value added in manufacturing of Sri Lanka in 1980 and the % of value added in manufacturing of Tunisia in 1990?
Offer a terse response. 13.65. What is the difference between the % of value added in manufacturing in Sri Lanka in 1980 and the % of value added in manufacturing in Venezuela in 1990?
Make the answer very short. 15.26. What is the difference between the % of value added in manufacturing of Tunisia in 1980 and the % of value added in manufacturing of Venezuela in 1990?
Offer a very short reply. 0.88. What is the difference between the % of value added in manufacturing in Burundi in 1980 and the % of value added in manufacturing in Sri Lanka in 1991?
Keep it short and to the point. 32.91. What is the difference between the % of value added in manufacturing of Burundi in 1980 and the % of value added in manufacturing of Tunisia in 1991?
Provide a short and direct response. 58.7. What is the difference between the % of value added in manufacturing in Burundi in 1980 and the % of value added in manufacturing in Venezuela in 1991?
Your answer should be very brief. 57.06. What is the difference between the % of value added in manufacturing in Sri Lanka in 1980 and the % of value added in manufacturing in Tunisia in 1991?
Offer a terse response. 13.12. What is the difference between the % of value added in manufacturing of Sri Lanka in 1980 and the % of value added in manufacturing of Venezuela in 1991?
Ensure brevity in your answer.  11.48. What is the difference between the % of value added in manufacturing of Tunisia in 1980 and the % of value added in manufacturing of Venezuela in 1991?
Your answer should be very brief. -2.89. What is the difference between the % of value added in manufacturing of Burundi in 1989 and the % of value added in manufacturing of Sri Lanka in 1990?
Make the answer very short. 34.05. What is the difference between the % of value added in manufacturing in Burundi in 1989 and the % of value added in manufacturing in Tunisia in 1990?
Provide a short and direct response. 66.03. What is the difference between the % of value added in manufacturing in Burundi in 1989 and the % of value added in manufacturing in Venezuela in 1990?
Offer a terse response. 67.64. What is the difference between the % of value added in manufacturing of Sri Lanka in 1989 and the % of value added in manufacturing of Tunisia in 1990?
Make the answer very short. 31.96. What is the difference between the % of value added in manufacturing of Sri Lanka in 1989 and the % of value added in manufacturing of Venezuela in 1990?
Keep it short and to the point. 33.57. What is the difference between the % of value added in manufacturing in Tunisia in 1989 and the % of value added in manufacturing in Venezuela in 1990?
Keep it short and to the point. -0.7. What is the difference between the % of value added in manufacturing in Burundi in 1989 and the % of value added in manufacturing in Sri Lanka in 1991?
Give a very brief answer. 39.71. What is the difference between the % of value added in manufacturing of Burundi in 1989 and the % of value added in manufacturing of Tunisia in 1991?
Your answer should be very brief. 65.5. What is the difference between the % of value added in manufacturing in Burundi in 1989 and the % of value added in manufacturing in Venezuela in 1991?
Give a very brief answer. 63.86. What is the difference between the % of value added in manufacturing in Sri Lanka in 1989 and the % of value added in manufacturing in Tunisia in 1991?
Your answer should be very brief. 31.43. What is the difference between the % of value added in manufacturing of Sri Lanka in 1989 and the % of value added in manufacturing of Venezuela in 1991?
Provide a succinct answer. 29.79. What is the difference between the % of value added in manufacturing of Tunisia in 1989 and the % of value added in manufacturing of Venezuela in 1991?
Offer a very short reply. -4.47. What is the difference between the % of value added in manufacturing in Burundi in 1990 and the % of value added in manufacturing in Sri Lanka in 1991?
Offer a terse response. 37.75. What is the difference between the % of value added in manufacturing of Burundi in 1990 and the % of value added in manufacturing of Tunisia in 1991?
Provide a succinct answer. 63.54. What is the difference between the % of value added in manufacturing in Burundi in 1990 and the % of value added in manufacturing in Venezuela in 1991?
Your response must be concise. 61.9. What is the difference between the % of value added in manufacturing of Sri Lanka in 1990 and the % of value added in manufacturing of Tunisia in 1991?
Provide a short and direct response. 31.45. What is the difference between the % of value added in manufacturing of Sri Lanka in 1990 and the % of value added in manufacturing of Venezuela in 1991?
Ensure brevity in your answer.  29.81. What is the difference between the % of value added in manufacturing of Tunisia in 1990 and the % of value added in manufacturing of Venezuela in 1991?
Provide a short and direct response. -2.17. What is the average % of value added in manufacturing in Burundi per year?
Your answer should be compact. 72.86. What is the average % of value added in manufacturing in Sri Lanka per year?
Offer a terse response. 36.36. What is the average % of value added in manufacturing in Tunisia per year?
Provide a short and direct response. 19.9. What is the average % of value added in manufacturing in Venezuela per year?
Ensure brevity in your answer.  22.53. In the year 1972, what is the difference between the % of value added in manufacturing of Burundi and % of value added in manufacturing of Sri Lanka?
Your answer should be compact. 26.24. In the year 1972, what is the difference between the % of value added in manufacturing of Burundi and % of value added in manufacturing of Tunisia?
Keep it short and to the point. 29.92. In the year 1972, what is the difference between the % of value added in manufacturing of Burundi and % of value added in manufacturing of Venezuela?
Your answer should be compact. 23.44. In the year 1972, what is the difference between the % of value added in manufacturing in Sri Lanka and % of value added in manufacturing in Tunisia?
Ensure brevity in your answer.  3.68. In the year 1972, what is the difference between the % of value added in manufacturing in Sri Lanka and % of value added in manufacturing in Venezuela?
Provide a succinct answer. -2.8. In the year 1972, what is the difference between the % of value added in manufacturing in Tunisia and % of value added in manufacturing in Venezuela?
Your response must be concise. -6.47. In the year 1973, what is the difference between the % of value added in manufacturing in Burundi and % of value added in manufacturing in Sri Lanka?
Your answer should be compact. 32.71. In the year 1973, what is the difference between the % of value added in manufacturing of Burundi and % of value added in manufacturing of Tunisia?
Offer a terse response. 35.72. In the year 1973, what is the difference between the % of value added in manufacturing in Burundi and % of value added in manufacturing in Venezuela?
Provide a short and direct response. 27.77. In the year 1973, what is the difference between the % of value added in manufacturing in Sri Lanka and % of value added in manufacturing in Tunisia?
Your response must be concise. 3.02. In the year 1973, what is the difference between the % of value added in manufacturing of Sri Lanka and % of value added in manufacturing of Venezuela?
Ensure brevity in your answer.  -4.94. In the year 1973, what is the difference between the % of value added in manufacturing in Tunisia and % of value added in manufacturing in Venezuela?
Give a very brief answer. -7.96. In the year 1974, what is the difference between the % of value added in manufacturing of Burundi and % of value added in manufacturing of Sri Lanka?
Your answer should be very brief. 31.23. In the year 1974, what is the difference between the % of value added in manufacturing in Burundi and % of value added in manufacturing in Tunisia?
Provide a short and direct response. 38.09. In the year 1974, what is the difference between the % of value added in manufacturing in Burundi and % of value added in manufacturing in Venezuela?
Make the answer very short. 36.16. In the year 1974, what is the difference between the % of value added in manufacturing in Sri Lanka and % of value added in manufacturing in Tunisia?
Ensure brevity in your answer.  6.87. In the year 1974, what is the difference between the % of value added in manufacturing of Sri Lanka and % of value added in manufacturing of Venezuela?
Offer a terse response. 4.93. In the year 1974, what is the difference between the % of value added in manufacturing in Tunisia and % of value added in manufacturing in Venezuela?
Provide a short and direct response. -1.94. In the year 1979, what is the difference between the % of value added in manufacturing of Burundi and % of value added in manufacturing of Sri Lanka?
Your response must be concise. 51.89. In the year 1979, what is the difference between the % of value added in manufacturing in Burundi and % of value added in manufacturing in Tunisia?
Provide a short and direct response. 63.65. In the year 1979, what is the difference between the % of value added in manufacturing of Burundi and % of value added in manufacturing of Venezuela?
Offer a very short reply. 63.26. In the year 1979, what is the difference between the % of value added in manufacturing of Sri Lanka and % of value added in manufacturing of Tunisia?
Your answer should be compact. 11.76. In the year 1979, what is the difference between the % of value added in manufacturing in Sri Lanka and % of value added in manufacturing in Venezuela?
Your response must be concise. 11.37. In the year 1979, what is the difference between the % of value added in manufacturing of Tunisia and % of value added in manufacturing of Venezuela?
Offer a very short reply. -0.38. In the year 1980, what is the difference between the % of value added in manufacturing of Burundi and % of value added in manufacturing of Sri Lanka?
Make the answer very short. 45.58. In the year 1980, what is the difference between the % of value added in manufacturing of Burundi and % of value added in manufacturing of Tunisia?
Provide a succinct answer. 59.96. In the year 1980, what is the difference between the % of value added in manufacturing in Burundi and % of value added in manufacturing in Venezuela?
Make the answer very short. 58.55. In the year 1980, what is the difference between the % of value added in manufacturing in Sri Lanka and % of value added in manufacturing in Tunisia?
Ensure brevity in your answer.  14.38. In the year 1980, what is the difference between the % of value added in manufacturing of Sri Lanka and % of value added in manufacturing of Venezuela?
Your response must be concise. 12.96. In the year 1980, what is the difference between the % of value added in manufacturing of Tunisia and % of value added in manufacturing of Venezuela?
Your response must be concise. -1.41. In the year 1989, what is the difference between the % of value added in manufacturing of Burundi and % of value added in manufacturing of Sri Lanka?
Provide a succinct answer. 34.07. In the year 1989, what is the difference between the % of value added in manufacturing of Burundi and % of value added in manufacturing of Tunisia?
Your response must be concise. 68.33. In the year 1989, what is the difference between the % of value added in manufacturing in Burundi and % of value added in manufacturing in Venezuela?
Keep it short and to the point. 65.42. In the year 1989, what is the difference between the % of value added in manufacturing in Sri Lanka and % of value added in manufacturing in Tunisia?
Your response must be concise. 34.27. In the year 1989, what is the difference between the % of value added in manufacturing of Sri Lanka and % of value added in manufacturing of Venezuela?
Your answer should be compact. 31.35. In the year 1989, what is the difference between the % of value added in manufacturing of Tunisia and % of value added in manufacturing of Venezuela?
Offer a terse response. -2.92. In the year 1990, what is the difference between the % of value added in manufacturing in Burundi and % of value added in manufacturing in Sri Lanka?
Your response must be concise. 32.09. In the year 1990, what is the difference between the % of value added in manufacturing of Burundi and % of value added in manufacturing of Tunisia?
Keep it short and to the point. 64.07. In the year 1990, what is the difference between the % of value added in manufacturing in Burundi and % of value added in manufacturing in Venezuela?
Ensure brevity in your answer.  65.68. In the year 1990, what is the difference between the % of value added in manufacturing of Sri Lanka and % of value added in manufacturing of Tunisia?
Your answer should be compact. 31.98. In the year 1990, what is the difference between the % of value added in manufacturing in Sri Lanka and % of value added in manufacturing in Venezuela?
Your response must be concise. 33.59. In the year 1990, what is the difference between the % of value added in manufacturing in Tunisia and % of value added in manufacturing in Venezuela?
Offer a terse response. 1.61. In the year 1991, what is the difference between the % of value added in manufacturing of Burundi and % of value added in manufacturing of Sri Lanka?
Make the answer very short. 38.22. In the year 1991, what is the difference between the % of value added in manufacturing in Burundi and % of value added in manufacturing in Tunisia?
Ensure brevity in your answer.  64. In the year 1991, what is the difference between the % of value added in manufacturing in Burundi and % of value added in manufacturing in Venezuela?
Your answer should be very brief. 62.37. In the year 1991, what is the difference between the % of value added in manufacturing in Sri Lanka and % of value added in manufacturing in Tunisia?
Your answer should be very brief. 25.79. In the year 1991, what is the difference between the % of value added in manufacturing of Sri Lanka and % of value added in manufacturing of Venezuela?
Your answer should be very brief. 24.15. In the year 1991, what is the difference between the % of value added in manufacturing of Tunisia and % of value added in manufacturing of Venezuela?
Provide a succinct answer. -1.64. What is the ratio of the % of value added in manufacturing in Burundi in 1972 to that in 1973?
Make the answer very short. 0.91. What is the ratio of the % of value added in manufacturing in Sri Lanka in 1972 to that in 1973?
Offer a terse response. 1.04. What is the ratio of the % of value added in manufacturing in Tunisia in 1972 to that in 1973?
Provide a succinct answer. 1.01. What is the ratio of the % of value added in manufacturing of Venezuela in 1972 to that in 1973?
Keep it short and to the point. 0.96. What is the ratio of the % of value added in manufacturing of Burundi in 1972 to that in 1974?
Provide a succinct answer. 0.9. What is the ratio of the % of value added in manufacturing of Tunisia in 1972 to that in 1974?
Offer a terse response. 1.1. What is the ratio of the % of value added in manufacturing of Venezuela in 1972 to that in 1974?
Offer a terse response. 1.29. What is the ratio of the % of value added in manufacturing of Burundi in 1972 to that in 1979?
Your answer should be very brief. 0.66. What is the ratio of the % of value added in manufacturing of Sri Lanka in 1972 to that in 1979?
Offer a very short reply. 0.94. What is the ratio of the % of value added in manufacturing of Tunisia in 1972 to that in 1979?
Provide a short and direct response. 1.35. What is the ratio of the % of value added in manufacturing of Venezuela in 1972 to that in 1979?
Make the answer very short. 1.68. What is the ratio of the % of value added in manufacturing in Burundi in 1972 to that in 1980?
Ensure brevity in your answer.  0.69. What is the ratio of the % of value added in manufacturing in Sri Lanka in 1972 to that in 1980?
Ensure brevity in your answer.  0.86. What is the ratio of the % of value added in manufacturing in Tunisia in 1972 to that in 1980?
Make the answer very short. 1.35. What is the ratio of the % of value added in manufacturing of Venezuela in 1972 to that in 1980?
Your answer should be compact. 1.58. What is the ratio of the % of value added in manufacturing in Burundi in 1972 to that in 1989?
Your answer should be compact. 0.64. What is the ratio of the % of value added in manufacturing in Sri Lanka in 1972 to that in 1989?
Keep it short and to the point. 0.55. What is the ratio of the % of value added in manufacturing of Tunisia in 1972 to that in 1989?
Offer a very short reply. 1.48. What is the ratio of the % of value added in manufacturing of Venezuela in 1972 to that in 1989?
Give a very brief answer. 1.59. What is the ratio of the % of value added in manufacturing in Burundi in 1972 to that in 1990?
Make the answer very short. 0.65. What is the ratio of the % of value added in manufacturing of Sri Lanka in 1972 to that in 1990?
Ensure brevity in your answer.  0.55. What is the ratio of the % of value added in manufacturing of Tunisia in 1972 to that in 1990?
Ensure brevity in your answer.  1.29. What is the ratio of the % of value added in manufacturing of Venezuela in 1972 to that in 1990?
Provide a succinct answer. 1.8. What is the ratio of the % of value added in manufacturing in Burundi in 1972 to that in 1991?
Your answer should be very brief. 0.65. What is the ratio of the % of value added in manufacturing in Sri Lanka in 1972 to that in 1991?
Give a very brief answer. 0.62. What is the ratio of the % of value added in manufacturing of Tunisia in 1972 to that in 1991?
Provide a succinct answer. 1.26. What is the ratio of the % of value added in manufacturing in Venezuela in 1972 to that in 1991?
Your answer should be compact. 1.47. What is the ratio of the % of value added in manufacturing in Sri Lanka in 1973 to that in 1974?
Give a very brief answer. 0.93. What is the ratio of the % of value added in manufacturing of Tunisia in 1973 to that in 1974?
Offer a terse response. 1.09. What is the ratio of the % of value added in manufacturing in Venezuela in 1973 to that in 1974?
Keep it short and to the point. 1.34. What is the ratio of the % of value added in manufacturing in Burundi in 1973 to that in 1979?
Give a very brief answer. 0.73. What is the ratio of the % of value added in manufacturing in Sri Lanka in 1973 to that in 1979?
Provide a short and direct response. 0.91. What is the ratio of the % of value added in manufacturing in Tunisia in 1973 to that in 1979?
Provide a succinct answer. 1.33. What is the ratio of the % of value added in manufacturing in Venezuela in 1973 to that in 1979?
Keep it short and to the point. 1.74. What is the ratio of the % of value added in manufacturing of Burundi in 1973 to that in 1980?
Your answer should be very brief. 0.76. What is the ratio of the % of value added in manufacturing of Sri Lanka in 1973 to that in 1980?
Give a very brief answer. 0.83. What is the ratio of the % of value added in manufacturing in Tunisia in 1973 to that in 1980?
Your answer should be compact. 1.33. What is the ratio of the % of value added in manufacturing in Venezuela in 1973 to that in 1980?
Provide a short and direct response. 1.64. What is the ratio of the % of value added in manufacturing in Burundi in 1973 to that in 1989?
Your answer should be compact. 0.7. What is the ratio of the % of value added in manufacturing of Sri Lanka in 1973 to that in 1989?
Offer a very short reply. 0.53. What is the ratio of the % of value added in manufacturing in Tunisia in 1973 to that in 1989?
Give a very brief answer. 1.46. What is the ratio of the % of value added in manufacturing in Venezuela in 1973 to that in 1989?
Provide a short and direct response. 1.65. What is the ratio of the % of value added in manufacturing in Burundi in 1973 to that in 1990?
Provide a short and direct response. 0.72. What is the ratio of the % of value added in manufacturing in Sri Lanka in 1973 to that in 1990?
Your answer should be compact. 0.53. What is the ratio of the % of value added in manufacturing in Tunisia in 1973 to that in 1990?
Provide a short and direct response. 1.28. What is the ratio of the % of value added in manufacturing of Venezuela in 1973 to that in 1990?
Keep it short and to the point. 1.87. What is the ratio of the % of value added in manufacturing in Burundi in 1973 to that in 1991?
Offer a terse response. 0.72. What is the ratio of the % of value added in manufacturing in Sri Lanka in 1973 to that in 1991?
Provide a succinct answer. 0.6. What is the ratio of the % of value added in manufacturing of Tunisia in 1973 to that in 1991?
Provide a short and direct response. 1.24. What is the ratio of the % of value added in manufacturing in Venezuela in 1973 to that in 1991?
Your response must be concise. 1.53. What is the ratio of the % of value added in manufacturing in Burundi in 1974 to that in 1979?
Give a very brief answer. 0.74. What is the ratio of the % of value added in manufacturing in Sri Lanka in 1974 to that in 1979?
Give a very brief answer. 0.97. What is the ratio of the % of value added in manufacturing of Tunisia in 1974 to that in 1979?
Make the answer very short. 1.22. What is the ratio of the % of value added in manufacturing in Venezuela in 1974 to that in 1979?
Offer a very short reply. 1.3. What is the ratio of the % of value added in manufacturing in Burundi in 1974 to that in 1980?
Keep it short and to the point. 0.77. What is the ratio of the % of value added in manufacturing in Sri Lanka in 1974 to that in 1980?
Give a very brief answer. 0.89. What is the ratio of the % of value added in manufacturing in Tunisia in 1974 to that in 1980?
Offer a terse response. 1.22. What is the ratio of the % of value added in manufacturing of Venezuela in 1974 to that in 1980?
Provide a succinct answer. 1.23. What is the ratio of the % of value added in manufacturing of Burundi in 1974 to that in 1989?
Ensure brevity in your answer.  0.71. What is the ratio of the % of value added in manufacturing of Sri Lanka in 1974 to that in 1989?
Offer a very short reply. 0.57. What is the ratio of the % of value added in manufacturing of Tunisia in 1974 to that in 1989?
Ensure brevity in your answer.  1.34. What is the ratio of the % of value added in manufacturing in Venezuela in 1974 to that in 1989?
Provide a succinct answer. 1.24. What is the ratio of the % of value added in manufacturing in Burundi in 1974 to that in 1990?
Provide a succinct answer. 0.72. What is the ratio of the % of value added in manufacturing in Sri Lanka in 1974 to that in 1990?
Keep it short and to the point. 0.57. What is the ratio of the % of value added in manufacturing of Tunisia in 1974 to that in 1990?
Ensure brevity in your answer.  1.17. What is the ratio of the % of value added in manufacturing of Venezuela in 1974 to that in 1990?
Give a very brief answer. 1.4. What is the ratio of the % of value added in manufacturing in Burundi in 1974 to that in 1991?
Offer a terse response. 0.72. What is the ratio of the % of value added in manufacturing in Sri Lanka in 1974 to that in 1991?
Your answer should be very brief. 0.64. What is the ratio of the % of value added in manufacturing of Tunisia in 1974 to that in 1991?
Your answer should be compact. 1.14. What is the ratio of the % of value added in manufacturing of Venezuela in 1974 to that in 1991?
Give a very brief answer. 1.14. What is the ratio of the % of value added in manufacturing in Burundi in 1979 to that in 1980?
Give a very brief answer. 1.05. What is the ratio of the % of value added in manufacturing in Sri Lanka in 1979 to that in 1980?
Your answer should be very brief. 0.92. What is the ratio of the % of value added in manufacturing in Tunisia in 1979 to that in 1980?
Make the answer very short. 1. What is the ratio of the % of value added in manufacturing of Venezuela in 1979 to that in 1980?
Make the answer very short. 0.94. What is the ratio of the % of value added in manufacturing of Burundi in 1979 to that in 1989?
Keep it short and to the point. 0.96. What is the ratio of the % of value added in manufacturing in Sri Lanka in 1979 to that in 1989?
Ensure brevity in your answer.  0.58. What is the ratio of the % of value added in manufacturing of Tunisia in 1979 to that in 1989?
Offer a terse response. 1.09. What is the ratio of the % of value added in manufacturing of Venezuela in 1979 to that in 1989?
Give a very brief answer. 0.95. What is the ratio of the % of value added in manufacturing in Sri Lanka in 1979 to that in 1990?
Provide a succinct answer. 0.58. What is the ratio of the % of value added in manufacturing of Tunisia in 1979 to that in 1990?
Provide a succinct answer. 0.96. What is the ratio of the % of value added in manufacturing of Venezuela in 1979 to that in 1990?
Provide a short and direct response. 1.07. What is the ratio of the % of value added in manufacturing in Burundi in 1979 to that in 1991?
Provide a succinct answer. 0.98. What is the ratio of the % of value added in manufacturing in Sri Lanka in 1979 to that in 1991?
Your answer should be compact. 0.66. What is the ratio of the % of value added in manufacturing in Tunisia in 1979 to that in 1991?
Provide a short and direct response. 0.93. What is the ratio of the % of value added in manufacturing of Venezuela in 1979 to that in 1991?
Your answer should be compact. 0.88. What is the ratio of the % of value added in manufacturing of Burundi in 1980 to that in 1989?
Provide a succinct answer. 0.92. What is the ratio of the % of value added in manufacturing of Sri Lanka in 1980 to that in 1989?
Keep it short and to the point. 0.64. What is the ratio of the % of value added in manufacturing in Tunisia in 1980 to that in 1989?
Make the answer very short. 1.1. What is the ratio of the % of value added in manufacturing in Venezuela in 1980 to that in 1989?
Your response must be concise. 1. What is the ratio of the % of value added in manufacturing in Burundi in 1980 to that in 1990?
Offer a very short reply. 0.94. What is the ratio of the % of value added in manufacturing in Sri Lanka in 1980 to that in 1990?
Offer a terse response. 0.64. What is the ratio of the % of value added in manufacturing of Tunisia in 1980 to that in 1990?
Provide a succinct answer. 0.96. What is the ratio of the % of value added in manufacturing of Venezuela in 1980 to that in 1990?
Your answer should be very brief. 1.14. What is the ratio of the % of value added in manufacturing of Burundi in 1980 to that in 1991?
Offer a terse response. 0.94. What is the ratio of the % of value added in manufacturing in Sri Lanka in 1980 to that in 1991?
Give a very brief answer. 0.72. What is the ratio of the % of value added in manufacturing of Tunisia in 1980 to that in 1991?
Make the answer very short. 0.93. What is the ratio of the % of value added in manufacturing in Burundi in 1989 to that in 1990?
Make the answer very short. 1.02. What is the ratio of the % of value added in manufacturing in Tunisia in 1989 to that in 1990?
Keep it short and to the point. 0.88. What is the ratio of the % of value added in manufacturing in Venezuela in 1989 to that in 1990?
Offer a very short reply. 1.13. What is the ratio of the % of value added in manufacturing of Burundi in 1989 to that in 1991?
Your answer should be very brief. 1.02. What is the ratio of the % of value added in manufacturing in Sri Lanka in 1989 to that in 1991?
Your answer should be compact. 1.13. What is the ratio of the % of value added in manufacturing in Tunisia in 1989 to that in 1991?
Ensure brevity in your answer.  0.85. What is the ratio of the % of value added in manufacturing in Venezuela in 1989 to that in 1991?
Provide a short and direct response. 0.92. What is the ratio of the % of value added in manufacturing in Sri Lanka in 1990 to that in 1991?
Offer a terse response. 1.13. What is the ratio of the % of value added in manufacturing in Tunisia in 1990 to that in 1991?
Offer a very short reply. 0.97. What is the ratio of the % of value added in manufacturing in Venezuela in 1990 to that in 1991?
Keep it short and to the point. 0.82. What is the difference between the highest and the second highest % of value added in manufacturing in Burundi?
Provide a succinct answer. 1.49. What is the difference between the highest and the second highest % of value added in manufacturing in Sri Lanka?
Offer a very short reply. 0.02. What is the difference between the highest and the second highest % of value added in manufacturing of Tunisia?
Provide a succinct answer. 0.31. What is the difference between the highest and the second highest % of value added in manufacturing of Venezuela?
Provide a short and direct response. 1.18. What is the difference between the highest and the lowest % of value added in manufacturing of Burundi?
Ensure brevity in your answer.  30.65. What is the difference between the highest and the lowest % of value added in manufacturing in Sri Lanka?
Provide a succinct answer. 23.81. What is the difference between the highest and the lowest % of value added in manufacturing of Tunisia?
Offer a terse response. 7.77. What is the difference between the highest and the lowest % of value added in manufacturing of Venezuela?
Your response must be concise. 14.72. 